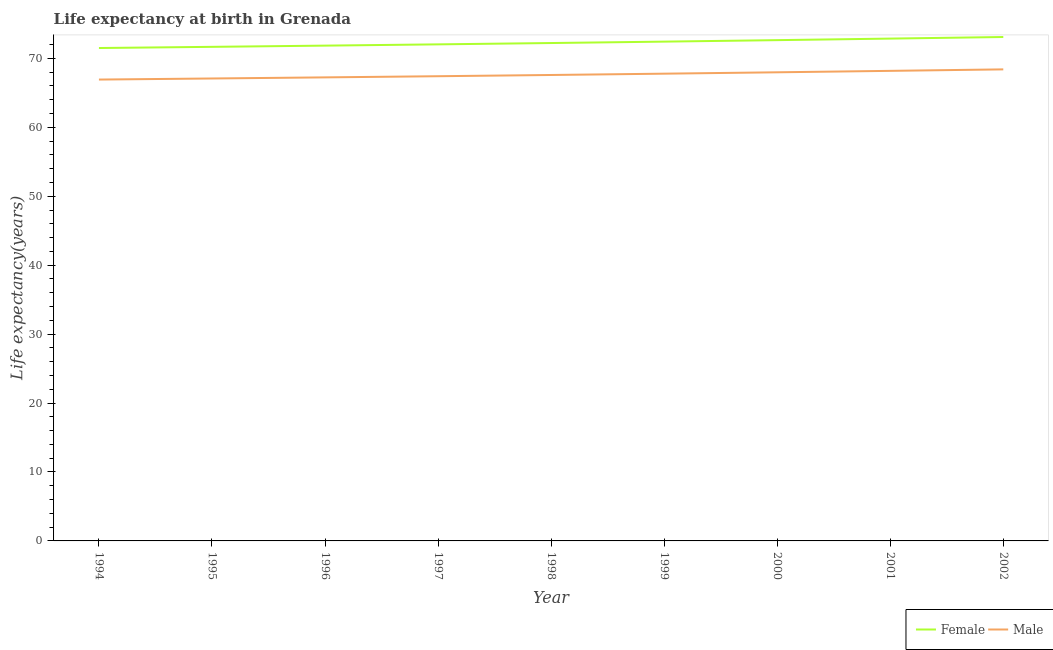How many different coloured lines are there?
Offer a terse response. 2. Is the number of lines equal to the number of legend labels?
Offer a terse response. Yes. What is the life expectancy(male) in 1999?
Your answer should be compact. 67.78. Across all years, what is the maximum life expectancy(male)?
Your response must be concise. 68.4. Across all years, what is the minimum life expectancy(male)?
Provide a succinct answer. 66.92. In which year was the life expectancy(male) maximum?
Give a very brief answer. 2002. What is the total life expectancy(male) in the graph?
Ensure brevity in your answer.  608.57. What is the difference between the life expectancy(male) in 1998 and that in 1999?
Give a very brief answer. -0.19. What is the difference between the life expectancy(female) in 1998 and the life expectancy(male) in 2002?
Provide a succinct answer. 3.82. What is the average life expectancy(male) per year?
Your answer should be very brief. 67.62. In the year 2002, what is the difference between the life expectancy(male) and life expectancy(female)?
Ensure brevity in your answer.  -4.7. What is the ratio of the life expectancy(female) in 1994 to that in 1999?
Give a very brief answer. 0.99. What is the difference between the highest and the second highest life expectancy(male)?
Ensure brevity in your answer.  0.22. What is the difference between the highest and the lowest life expectancy(male)?
Your answer should be very brief. 1.48. Is the sum of the life expectancy(male) in 1994 and 1996 greater than the maximum life expectancy(female) across all years?
Your response must be concise. Yes. Is the life expectancy(male) strictly greater than the life expectancy(female) over the years?
Keep it short and to the point. No. Is the life expectancy(male) strictly less than the life expectancy(female) over the years?
Offer a very short reply. Yes. How many lines are there?
Make the answer very short. 2. Does the graph contain any zero values?
Offer a terse response. No. Does the graph contain grids?
Ensure brevity in your answer.  No. How are the legend labels stacked?
Give a very brief answer. Horizontal. What is the title of the graph?
Offer a terse response. Life expectancy at birth in Grenada. Does "Rural" appear as one of the legend labels in the graph?
Keep it short and to the point. No. What is the label or title of the Y-axis?
Give a very brief answer. Life expectancy(years). What is the Life expectancy(years) of Female in 1994?
Keep it short and to the point. 71.5. What is the Life expectancy(years) in Male in 1994?
Give a very brief answer. 66.92. What is the Life expectancy(years) in Female in 1995?
Provide a succinct answer. 71.67. What is the Life expectancy(years) of Male in 1995?
Your answer should be compact. 67.08. What is the Life expectancy(years) of Female in 1996?
Make the answer very short. 71.85. What is the Life expectancy(years) of Male in 1996?
Provide a succinct answer. 67.24. What is the Life expectancy(years) of Female in 1997?
Give a very brief answer. 72.03. What is the Life expectancy(years) in Male in 1997?
Your answer should be very brief. 67.41. What is the Life expectancy(years) of Female in 1998?
Your answer should be compact. 72.22. What is the Life expectancy(years) of Male in 1998?
Offer a very short reply. 67.59. What is the Life expectancy(years) in Female in 1999?
Provide a short and direct response. 72.43. What is the Life expectancy(years) in Male in 1999?
Ensure brevity in your answer.  67.78. What is the Life expectancy(years) in Female in 2000?
Keep it short and to the point. 72.64. What is the Life expectancy(years) of Male in 2000?
Keep it short and to the point. 67.98. What is the Life expectancy(years) of Female in 2001?
Give a very brief answer. 72.86. What is the Life expectancy(years) in Male in 2001?
Provide a succinct answer. 68.19. What is the Life expectancy(years) of Female in 2002?
Ensure brevity in your answer.  73.1. What is the Life expectancy(years) of Male in 2002?
Make the answer very short. 68.4. Across all years, what is the maximum Life expectancy(years) of Female?
Provide a short and direct response. 73.1. Across all years, what is the maximum Life expectancy(years) of Male?
Your response must be concise. 68.4. Across all years, what is the minimum Life expectancy(years) of Female?
Your answer should be compact. 71.5. Across all years, what is the minimum Life expectancy(years) in Male?
Make the answer very short. 66.92. What is the total Life expectancy(years) in Female in the graph?
Provide a succinct answer. 650.29. What is the total Life expectancy(years) of Male in the graph?
Offer a very short reply. 608.57. What is the difference between the Life expectancy(years) in Female in 1994 and that in 1995?
Your answer should be compact. -0.17. What is the difference between the Life expectancy(years) of Male in 1994 and that in 1995?
Make the answer very short. -0.16. What is the difference between the Life expectancy(years) in Female in 1994 and that in 1996?
Make the answer very short. -0.35. What is the difference between the Life expectancy(years) of Male in 1994 and that in 1996?
Make the answer very short. -0.32. What is the difference between the Life expectancy(years) in Female in 1994 and that in 1997?
Your answer should be very brief. -0.53. What is the difference between the Life expectancy(years) of Male in 1994 and that in 1997?
Your answer should be very brief. -0.48. What is the difference between the Life expectancy(years) of Female in 1994 and that in 1998?
Your answer should be compact. -0.72. What is the difference between the Life expectancy(years) of Male in 1994 and that in 1998?
Offer a terse response. -0.66. What is the difference between the Life expectancy(years) in Female in 1994 and that in 1999?
Offer a very short reply. -0.93. What is the difference between the Life expectancy(years) in Male in 1994 and that in 1999?
Offer a terse response. -0.85. What is the difference between the Life expectancy(years) of Female in 1994 and that in 2000?
Keep it short and to the point. -1.14. What is the difference between the Life expectancy(years) of Male in 1994 and that in 2000?
Offer a terse response. -1.05. What is the difference between the Life expectancy(years) of Female in 1994 and that in 2001?
Your answer should be compact. -1.37. What is the difference between the Life expectancy(years) of Male in 1994 and that in 2001?
Your answer should be very brief. -1.26. What is the difference between the Life expectancy(years) of Female in 1994 and that in 2002?
Your response must be concise. -1.6. What is the difference between the Life expectancy(years) of Male in 1994 and that in 2002?
Provide a succinct answer. -1.48. What is the difference between the Life expectancy(years) of Female in 1995 and that in 1996?
Provide a succinct answer. -0.18. What is the difference between the Life expectancy(years) of Male in 1995 and that in 1996?
Your answer should be compact. -0.16. What is the difference between the Life expectancy(years) of Female in 1995 and that in 1997?
Keep it short and to the point. -0.36. What is the difference between the Life expectancy(years) of Male in 1995 and that in 1997?
Your answer should be compact. -0.33. What is the difference between the Life expectancy(years) in Female in 1995 and that in 1998?
Make the answer very short. -0.55. What is the difference between the Life expectancy(years) of Male in 1995 and that in 1998?
Provide a short and direct response. -0.51. What is the difference between the Life expectancy(years) of Female in 1995 and that in 1999?
Offer a very short reply. -0.76. What is the difference between the Life expectancy(years) in Male in 1995 and that in 1999?
Offer a terse response. -0.7. What is the difference between the Life expectancy(years) in Female in 1995 and that in 2000?
Provide a succinct answer. -0.97. What is the difference between the Life expectancy(years) of Male in 1995 and that in 2000?
Provide a succinct answer. -0.9. What is the difference between the Life expectancy(years) in Female in 1995 and that in 2001?
Keep it short and to the point. -1.2. What is the difference between the Life expectancy(years) in Male in 1995 and that in 2001?
Provide a succinct answer. -1.11. What is the difference between the Life expectancy(years) in Female in 1995 and that in 2002?
Provide a short and direct response. -1.43. What is the difference between the Life expectancy(years) in Male in 1995 and that in 2002?
Keep it short and to the point. -1.32. What is the difference between the Life expectancy(years) in Female in 1996 and that in 1997?
Provide a succinct answer. -0.18. What is the difference between the Life expectancy(years) of Male in 1996 and that in 1997?
Your response must be concise. -0.17. What is the difference between the Life expectancy(years) in Female in 1996 and that in 1998?
Ensure brevity in your answer.  -0.38. What is the difference between the Life expectancy(years) of Male in 1996 and that in 1998?
Ensure brevity in your answer.  -0.35. What is the difference between the Life expectancy(years) of Female in 1996 and that in 1999?
Offer a very short reply. -0.58. What is the difference between the Life expectancy(years) of Male in 1996 and that in 1999?
Your answer should be compact. -0.54. What is the difference between the Life expectancy(years) in Female in 1996 and that in 2000?
Keep it short and to the point. -0.8. What is the difference between the Life expectancy(years) of Male in 1996 and that in 2000?
Your answer should be compact. -0.74. What is the difference between the Life expectancy(years) of Female in 1996 and that in 2001?
Your answer should be very brief. -1.02. What is the difference between the Life expectancy(years) of Male in 1996 and that in 2001?
Provide a short and direct response. -0.95. What is the difference between the Life expectancy(years) in Female in 1996 and that in 2002?
Ensure brevity in your answer.  -1.25. What is the difference between the Life expectancy(years) in Male in 1996 and that in 2002?
Your response must be concise. -1.16. What is the difference between the Life expectancy(years) in Female in 1997 and that in 1998?
Your answer should be very brief. -0.19. What is the difference between the Life expectancy(years) of Male in 1997 and that in 1998?
Ensure brevity in your answer.  -0.18. What is the difference between the Life expectancy(years) of Female in 1997 and that in 1999?
Make the answer very short. -0.4. What is the difference between the Life expectancy(years) of Male in 1997 and that in 1999?
Your answer should be compact. -0.37. What is the difference between the Life expectancy(years) of Female in 1997 and that in 2000?
Your answer should be very brief. -0.61. What is the difference between the Life expectancy(years) of Male in 1997 and that in 2000?
Provide a short and direct response. -0.57. What is the difference between the Life expectancy(years) of Female in 1997 and that in 2001?
Offer a terse response. -0.84. What is the difference between the Life expectancy(years) in Male in 1997 and that in 2001?
Offer a very short reply. -0.78. What is the difference between the Life expectancy(years) of Female in 1997 and that in 2002?
Your answer should be very brief. -1.07. What is the difference between the Life expectancy(years) of Male in 1997 and that in 2002?
Give a very brief answer. -0.99. What is the difference between the Life expectancy(years) in Female in 1998 and that in 1999?
Ensure brevity in your answer.  -0.2. What is the difference between the Life expectancy(years) of Male in 1998 and that in 1999?
Provide a short and direct response. -0.19. What is the difference between the Life expectancy(years) of Female in 1998 and that in 2000?
Offer a terse response. -0.42. What is the difference between the Life expectancy(years) in Male in 1998 and that in 2000?
Offer a very short reply. -0.39. What is the difference between the Life expectancy(years) in Female in 1998 and that in 2001?
Make the answer very short. -0.64. What is the difference between the Life expectancy(years) of Male in 1998 and that in 2001?
Give a very brief answer. -0.6. What is the difference between the Life expectancy(years) of Female in 1998 and that in 2002?
Make the answer very short. -0.87. What is the difference between the Life expectancy(years) of Male in 1998 and that in 2002?
Keep it short and to the point. -0.81. What is the difference between the Life expectancy(years) in Female in 1999 and that in 2000?
Your answer should be very brief. -0.21. What is the difference between the Life expectancy(years) in Female in 1999 and that in 2001?
Provide a succinct answer. -0.44. What is the difference between the Life expectancy(years) of Male in 1999 and that in 2001?
Your answer should be very brief. -0.41. What is the difference between the Life expectancy(years) of Female in 1999 and that in 2002?
Your answer should be compact. -0.67. What is the difference between the Life expectancy(years) in Male in 1999 and that in 2002?
Keep it short and to the point. -0.62. What is the difference between the Life expectancy(years) of Female in 2000 and that in 2001?
Your response must be concise. -0.22. What is the difference between the Life expectancy(years) in Male in 2000 and that in 2001?
Provide a succinct answer. -0.21. What is the difference between the Life expectancy(years) in Female in 2000 and that in 2002?
Offer a terse response. -0.46. What is the difference between the Life expectancy(years) in Male in 2000 and that in 2002?
Keep it short and to the point. -0.42. What is the difference between the Life expectancy(years) in Female in 2001 and that in 2002?
Offer a very short reply. -0.23. What is the difference between the Life expectancy(years) of Male in 2001 and that in 2002?
Keep it short and to the point. -0.21. What is the difference between the Life expectancy(years) of Female in 1994 and the Life expectancy(years) of Male in 1995?
Your answer should be very brief. 4.42. What is the difference between the Life expectancy(years) of Female in 1994 and the Life expectancy(years) of Male in 1996?
Give a very brief answer. 4.26. What is the difference between the Life expectancy(years) of Female in 1994 and the Life expectancy(years) of Male in 1997?
Provide a short and direct response. 4.09. What is the difference between the Life expectancy(years) in Female in 1994 and the Life expectancy(years) in Male in 1998?
Offer a very short reply. 3.91. What is the difference between the Life expectancy(years) in Female in 1994 and the Life expectancy(years) in Male in 1999?
Your answer should be very brief. 3.72. What is the difference between the Life expectancy(years) of Female in 1994 and the Life expectancy(years) of Male in 2000?
Keep it short and to the point. 3.52. What is the difference between the Life expectancy(years) in Female in 1994 and the Life expectancy(years) in Male in 2001?
Provide a succinct answer. 3.31. What is the difference between the Life expectancy(years) in Female in 1994 and the Life expectancy(years) in Male in 2002?
Ensure brevity in your answer.  3.1. What is the difference between the Life expectancy(years) of Female in 1995 and the Life expectancy(years) of Male in 1996?
Offer a terse response. 4.43. What is the difference between the Life expectancy(years) in Female in 1995 and the Life expectancy(years) in Male in 1997?
Make the answer very short. 4.26. What is the difference between the Life expectancy(years) of Female in 1995 and the Life expectancy(years) of Male in 1998?
Keep it short and to the point. 4.08. What is the difference between the Life expectancy(years) in Female in 1995 and the Life expectancy(years) in Male in 1999?
Make the answer very short. 3.89. What is the difference between the Life expectancy(years) in Female in 1995 and the Life expectancy(years) in Male in 2000?
Your answer should be compact. 3.69. What is the difference between the Life expectancy(years) in Female in 1995 and the Life expectancy(years) in Male in 2001?
Ensure brevity in your answer.  3.48. What is the difference between the Life expectancy(years) in Female in 1995 and the Life expectancy(years) in Male in 2002?
Provide a short and direct response. 3.27. What is the difference between the Life expectancy(years) of Female in 1996 and the Life expectancy(years) of Male in 1997?
Offer a very short reply. 4.44. What is the difference between the Life expectancy(years) of Female in 1996 and the Life expectancy(years) of Male in 1998?
Offer a terse response. 4.26. What is the difference between the Life expectancy(years) in Female in 1996 and the Life expectancy(years) in Male in 1999?
Give a very brief answer. 4.07. What is the difference between the Life expectancy(years) in Female in 1996 and the Life expectancy(years) in Male in 2000?
Provide a succinct answer. 3.87. What is the difference between the Life expectancy(years) in Female in 1996 and the Life expectancy(years) in Male in 2001?
Keep it short and to the point. 3.66. What is the difference between the Life expectancy(years) in Female in 1996 and the Life expectancy(years) in Male in 2002?
Ensure brevity in your answer.  3.45. What is the difference between the Life expectancy(years) in Female in 1997 and the Life expectancy(years) in Male in 1998?
Offer a terse response. 4.44. What is the difference between the Life expectancy(years) of Female in 1997 and the Life expectancy(years) of Male in 1999?
Offer a terse response. 4.25. What is the difference between the Life expectancy(years) in Female in 1997 and the Life expectancy(years) in Male in 2000?
Your answer should be compact. 4.05. What is the difference between the Life expectancy(years) of Female in 1997 and the Life expectancy(years) of Male in 2001?
Provide a succinct answer. 3.84. What is the difference between the Life expectancy(years) in Female in 1997 and the Life expectancy(years) in Male in 2002?
Your answer should be compact. 3.63. What is the difference between the Life expectancy(years) in Female in 1998 and the Life expectancy(years) in Male in 1999?
Provide a short and direct response. 4.45. What is the difference between the Life expectancy(years) of Female in 1998 and the Life expectancy(years) of Male in 2000?
Offer a terse response. 4.25. What is the difference between the Life expectancy(years) in Female in 1998 and the Life expectancy(years) in Male in 2001?
Ensure brevity in your answer.  4.04. What is the difference between the Life expectancy(years) in Female in 1998 and the Life expectancy(years) in Male in 2002?
Your response must be concise. 3.82. What is the difference between the Life expectancy(years) of Female in 1999 and the Life expectancy(years) of Male in 2000?
Provide a short and direct response. 4.45. What is the difference between the Life expectancy(years) in Female in 1999 and the Life expectancy(years) in Male in 2001?
Offer a very short reply. 4.24. What is the difference between the Life expectancy(years) of Female in 1999 and the Life expectancy(years) of Male in 2002?
Provide a succinct answer. 4.03. What is the difference between the Life expectancy(years) of Female in 2000 and the Life expectancy(years) of Male in 2001?
Your answer should be very brief. 4.46. What is the difference between the Life expectancy(years) of Female in 2000 and the Life expectancy(years) of Male in 2002?
Your answer should be compact. 4.24. What is the difference between the Life expectancy(years) of Female in 2001 and the Life expectancy(years) of Male in 2002?
Keep it short and to the point. 4.46. What is the average Life expectancy(years) in Female per year?
Your response must be concise. 72.25. What is the average Life expectancy(years) of Male per year?
Your answer should be very brief. 67.62. In the year 1994, what is the difference between the Life expectancy(years) of Female and Life expectancy(years) of Male?
Keep it short and to the point. 4.58. In the year 1995, what is the difference between the Life expectancy(years) of Female and Life expectancy(years) of Male?
Provide a succinct answer. 4.59. In the year 1996, what is the difference between the Life expectancy(years) of Female and Life expectancy(years) of Male?
Offer a very short reply. 4.61. In the year 1997, what is the difference between the Life expectancy(years) in Female and Life expectancy(years) in Male?
Your response must be concise. 4.62. In the year 1998, what is the difference between the Life expectancy(years) in Female and Life expectancy(years) in Male?
Provide a short and direct response. 4.64. In the year 1999, what is the difference between the Life expectancy(years) of Female and Life expectancy(years) of Male?
Keep it short and to the point. 4.65. In the year 2000, what is the difference between the Life expectancy(years) of Female and Life expectancy(years) of Male?
Keep it short and to the point. 4.67. In the year 2001, what is the difference between the Life expectancy(years) in Female and Life expectancy(years) in Male?
Provide a short and direct response. 4.68. In the year 2002, what is the difference between the Life expectancy(years) in Female and Life expectancy(years) in Male?
Your answer should be very brief. 4.7. What is the ratio of the Life expectancy(years) in Female in 1994 to that in 1995?
Keep it short and to the point. 1. What is the ratio of the Life expectancy(years) of Male in 1994 to that in 1995?
Keep it short and to the point. 1. What is the ratio of the Life expectancy(years) in Female in 1994 to that in 1996?
Ensure brevity in your answer.  1. What is the ratio of the Life expectancy(years) of Male in 1994 to that in 1996?
Your answer should be very brief. 1. What is the ratio of the Life expectancy(years) in Female in 1994 to that in 1997?
Provide a short and direct response. 0.99. What is the ratio of the Life expectancy(years) of Female in 1994 to that in 1998?
Your answer should be compact. 0.99. What is the ratio of the Life expectancy(years) of Male in 1994 to that in 1998?
Your response must be concise. 0.99. What is the ratio of the Life expectancy(years) of Female in 1994 to that in 1999?
Make the answer very short. 0.99. What is the ratio of the Life expectancy(years) in Male in 1994 to that in 1999?
Offer a terse response. 0.99. What is the ratio of the Life expectancy(years) in Female in 1994 to that in 2000?
Ensure brevity in your answer.  0.98. What is the ratio of the Life expectancy(years) in Male in 1994 to that in 2000?
Offer a very short reply. 0.98. What is the ratio of the Life expectancy(years) in Female in 1994 to that in 2001?
Make the answer very short. 0.98. What is the ratio of the Life expectancy(years) of Male in 1994 to that in 2001?
Ensure brevity in your answer.  0.98. What is the ratio of the Life expectancy(years) of Female in 1994 to that in 2002?
Your answer should be very brief. 0.98. What is the ratio of the Life expectancy(years) of Male in 1994 to that in 2002?
Give a very brief answer. 0.98. What is the ratio of the Life expectancy(years) in Female in 1995 to that in 1996?
Give a very brief answer. 1. What is the ratio of the Life expectancy(years) in Female in 1995 to that in 1997?
Your answer should be very brief. 0.99. What is the ratio of the Life expectancy(years) in Male in 1995 to that in 1997?
Offer a terse response. 1. What is the ratio of the Life expectancy(years) of Female in 1995 to that in 1998?
Ensure brevity in your answer.  0.99. What is the ratio of the Life expectancy(years) in Female in 1995 to that in 2000?
Give a very brief answer. 0.99. What is the ratio of the Life expectancy(years) in Male in 1995 to that in 2000?
Offer a very short reply. 0.99. What is the ratio of the Life expectancy(years) in Female in 1995 to that in 2001?
Make the answer very short. 0.98. What is the ratio of the Life expectancy(years) in Male in 1995 to that in 2001?
Give a very brief answer. 0.98. What is the ratio of the Life expectancy(years) of Female in 1995 to that in 2002?
Make the answer very short. 0.98. What is the ratio of the Life expectancy(years) in Male in 1995 to that in 2002?
Your response must be concise. 0.98. What is the ratio of the Life expectancy(years) of Male in 1996 to that in 1997?
Offer a very short reply. 1. What is the ratio of the Life expectancy(years) in Female in 1996 to that in 1998?
Keep it short and to the point. 0.99. What is the ratio of the Life expectancy(years) of Male in 1996 to that in 2001?
Your answer should be very brief. 0.99. What is the ratio of the Life expectancy(years) of Female in 1996 to that in 2002?
Your answer should be very brief. 0.98. What is the ratio of the Life expectancy(years) in Male in 1996 to that in 2002?
Provide a short and direct response. 0.98. What is the ratio of the Life expectancy(years) in Female in 1997 to that in 1998?
Provide a succinct answer. 1. What is the ratio of the Life expectancy(years) in Female in 1997 to that in 1999?
Give a very brief answer. 0.99. What is the ratio of the Life expectancy(years) in Female in 1997 to that in 2000?
Offer a terse response. 0.99. What is the ratio of the Life expectancy(years) of Male in 1997 to that in 2001?
Your answer should be very brief. 0.99. What is the ratio of the Life expectancy(years) in Female in 1997 to that in 2002?
Offer a very short reply. 0.99. What is the ratio of the Life expectancy(years) of Male in 1997 to that in 2002?
Offer a terse response. 0.99. What is the ratio of the Life expectancy(years) of Male in 1998 to that in 1999?
Give a very brief answer. 1. What is the ratio of the Life expectancy(years) in Female in 1998 to that in 2000?
Offer a very short reply. 0.99. What is the ratio of the Life expectancy(years) of Male in 1998 to that in 2000?
Offer a terse response. 0.99. What is the ratio of the Life expectancy(years) in Female in 1998 to that in 2001?
Give a very brief answer. 0.99. What is the ratio of the Life expectancy(years) of Male in 1998 to that in 2001?
Offer a very short reply. 0.99. What is the ratio of the Life expectancy(years) of Male in 1998 to that in 2002?
Your answer should be very brief. 0.99. What is the ratio of the Life expectancy(years) in Male in 1999 to that in 2000?
Your answer should be very brief. 1. What is the ratio of the Life expectancy(years) in Female in 1999 to that in 2001?
Give a very brief answer. 0.99. What is the ratio of the Life expectancy(years) in Male in 1999 to that in 2001?
Provide a succinct answer. 0.99. What is the ratio of the Life expectancy(years) in Female in 1999 to that in 2002?
Keep it short and to the point. 0.99. What is the ratio of the Life expectancy(years) of Male in 1999 to that in 2002?
Your answer should be compact. 0.99. What is the ratio of the Life expectancy(years) in Male in 2000 to that in 2001?
Provide a succinct answer. 1. What is the ratio of the Life expectancy(years) in Male in 2001 to that in 2002?
Offer a very short reply. 1. What is the difference between the highest and the second highest Life expectancy(years) in Female?
Provide a short and direct response. 0.23. What is the difference between the highest and the second highest Life expectancy(years) of Male?
Give a very brief answer. 0.21. What is the difference between the highest and the lowest Life expectancy(years) in Female?
Ensure brevity in your answer.  1.6. What is the difference between the highest and the lowest Life expectancy(years) in Male?
Keep it short and to the point. 1.48. 